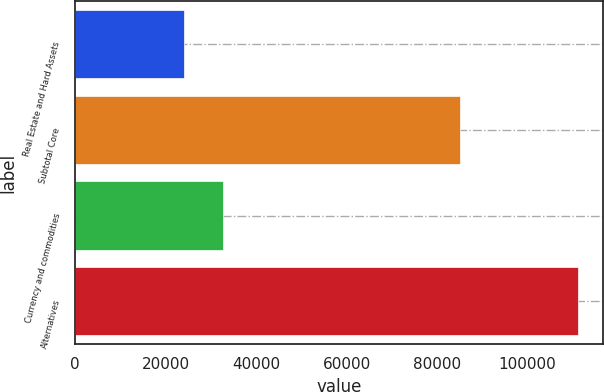<chart> <loc_0><loc_0><loc_500><loc_500><bar_chart><fcel>Real Estate and Hard Assets<fcel>Subtotal Core<fcel>Currency and commodities<fcel>Alternatives<nl><fcel>24012<fcel>85026<fcel>32722.2<fcel>111114<nl></chart> 